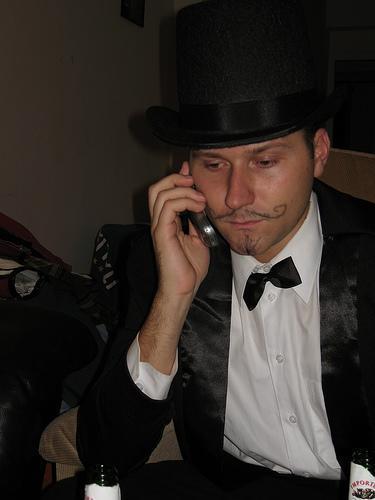How many drink bottles can be seen?
Give a very brief answer. 2. How many phones are there?
Give a very brief answer. 1. How many buttons do you see below the tie?
Give a very brief answer. 3. 